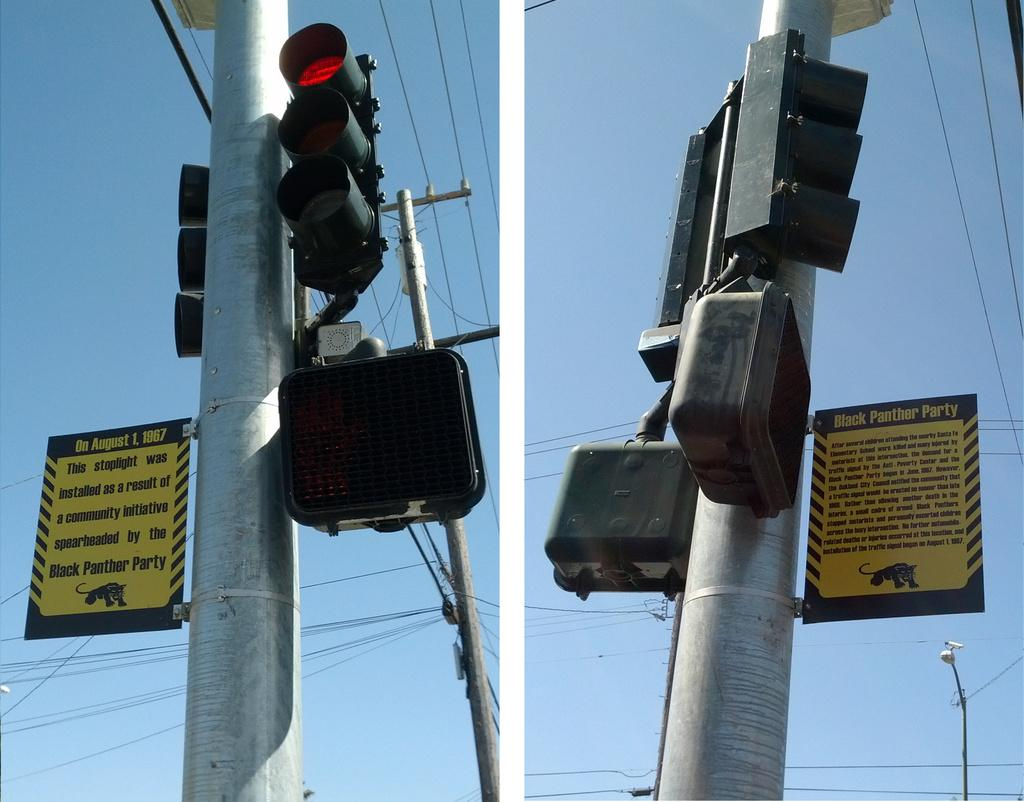Provide a one-sentence caption for the provided image. Two sets of traffic lights with an attached sign saying they were installed by the Black Panthers. 